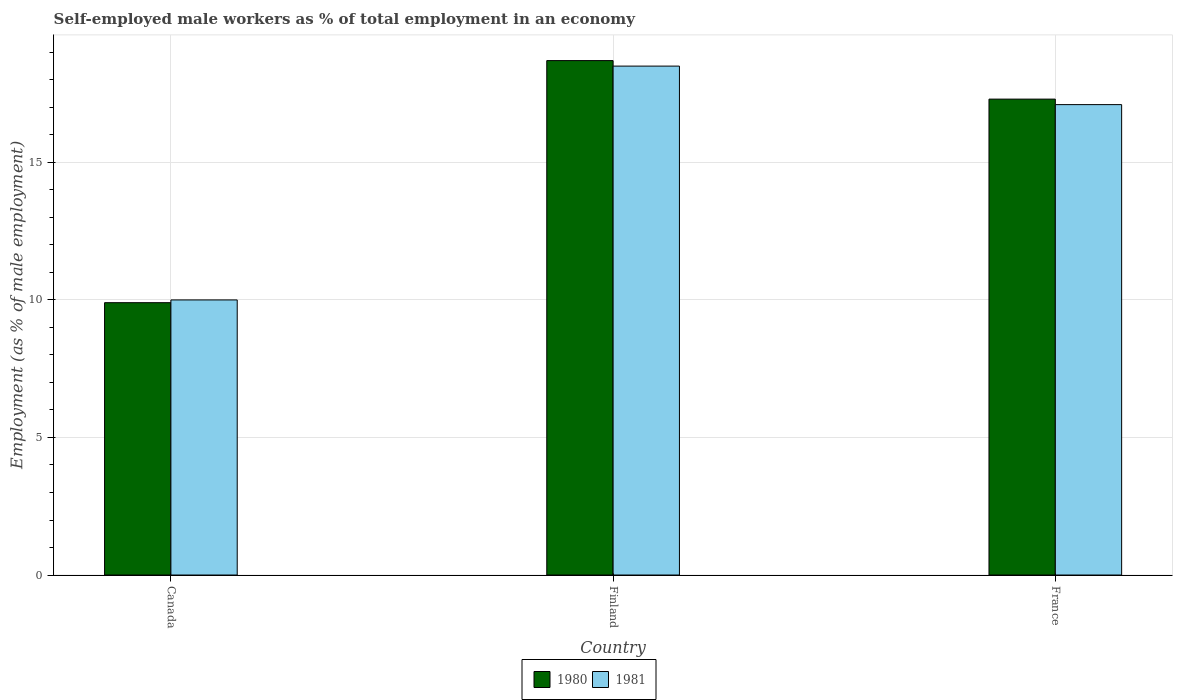Are the number of bars per tick equal to the number of legend labels?
Ensure brevity in your answer.  Yes. How many bars are there on the 3rd tick from the left?
Make the answer very short. 2. How many bars are there on the 3rd tick from the right?
Provide a succinct answer. 2. What is the label of the 2nd group of bars from the left?
Ensure brevity in your answer.  Finland. In how many cases, is the number of bars for a given country not equal to the number of legend labels?
Offer a terse response. 0. What is the percentage of self-employed male workers in 1980 in France?
Your answer should be very brief. 17.3. Across all countries, what is the maximum percentage of self-employed male workers in 1980?
Your answer should be compact. 18.7. What is the total percentage of self-employed male workers in 1980 in the graph?
Offer a terse response. 45.9. What is the difference between the percentage of self-employed male workers in 1980 in Canada and that in France?
Provide a short and direct response. -7.4. What is the difference between the percentage of self-employed male workers in 1980 in Finland and the percentage of self-employed male workers in 1981 in Canada?
Provide a short and direct response. 8.7. What is the average percentage of self-employed male workers in 1980 per country?
Your answer should be compact. 15.3. What is the difference between the percentage of self-employed male workers of/in 1981 and percentage of self-employed male workers of/in 1980 in France?
Give a very brief answer. -0.2. In how many countries, is the percentage of self-employed male workers in 1980 greater than 18 %?
Offer a very short reply. 1. What is the ratio of the percentage of self-employed male workers in 1980 in Canada to that in France?
Your answer should be very brief. 0.57. Is the difference between the percentage of self-employed male workers in 1981 in Finland and France greater than the difference between the percentage of self-employed male workers in 1980 in Finland and France?
Give a very brief answer. No. What is the difference between the highest and the second highest percentage of self-employed male workers in 1981?
Give a very brief answer. -1.4. What is the difference between the highest and the lowest percentage of self-employed male workers in 1980?
Keep it short and to the point. 8.8. What does the 2nd bar from the left in Finland represents?
Offer a terse response. 1981. How many bars are there?
Make the answer very short. 6. Are all the bars in the graph horizontal?
Your response must be concise. No. How many countries are there in the graph?
Your answer should be very brief. 3. Does the graph contain any zero values?
Provide a succinct answer. No. How are the legend labels stacked?
Your answer should be compact. Horizontal. What is the title of the graph?
Your response must be concise. Self-employed male workers as % of total employment in an economy. Does "1975" appear as one of the legend labels in the graph?
Your answer should be compact. No. What is the label or title of the Y-axis?
Offer a terse response. Employment (as % of male employment). What is the Employment (as % of male employment) in 1980 in Canada?
Provide a short and direct response. 9.9. What is the Employment (as % of male employment) of 1981 in Canada?
Provide a succinct answer. 10. What is the Employment (as % of male employment) of 1980 in Finland?
Ensure brevity in your answer.  18.7. What is the Employment (as % of male employment) in 1981 in Finland?
Your response must be concise. 18.5. What is the Employment (as % of male employment) of 1980 in France?
Give a very brief answer. 17.3. What is the Employment (as % of male employment) of 1981 in France?
Give a very brief answer. 17.1. Across all countries, what is the maximum Employment (as % of male employment) in 1980?
Your answer should be very brief. 18.7. Across all countries, what is the maximum Employment (as % of male employment) of 1981?
Your answer should be compact. 18.5. Across all countries, what is the minimum Employment (as % of male employment) of 1980?
Offer a very short reply. 9.9. Across all countries, what is the minimum Employment (as % of male employment) of 1981?
Your answer should be very brief. 10. What is the total Employment (as % of male employment) of 1980 in the graph?
Your response must be concise. 45.9. What is the total Employment (as % of male employment) of 1981 in the graph?
Provide a short and direct response. 45.6. What is the difference between the Employment (as % of male employment) of 1980 in Canada and that in Finland?
Provide a short and direct response. -8.8. What is the difference between the Employment (as % of male employment) in 1980 in Canada and that in France?
Provide a short and direct response. -7.4. What is the difference between the Employment (as % of male employment) of 1981 in Canada and that in France?
Your answer should be compact. -7.1. What is the difference between the Employment (as % of male employment) in 1980 in Canada and the Employment (as % of male employment) in 1981 in Finland?
Provide a short and direct response. -8.6. What is the difference between the Employment (as % of male employment) of 1980 in Canada and the Employment (as % of male employment) of 1981 in France?
Ensure brevity in your answer.  -7.2. What is the difference between the Employment (as % of male employment) of 1980 in Finland and the Employment (as % of male employment) of 1981 in France?
Make the answer very short. 1.6. What is the average Employment (as % of male employment) of 1981 per country?
Provide a short and direct response. 15.2. What is the ratio of the Employment (as % of male employment) in 1980 in Canada to that in Finland?
Make the answer very short. 0.53. What is the ratio of the Employment (as % of male employment) of 1981 in Canada to that in Finland?
Keep it short and to the point. 0.54. What is the ratio of the Employment (as % of male employment) of 1980 in Canada to that in France?
Offer a very short reply. 0.57. What is the ratio of the Employment (as % of male employment) of 1981 in Canada to that in France?
Make the answer very short. 0.58. What is the ratio of the Employment (as % of male employment) in 1980 in Finland to that in France?
Offer a terse response. 1.08. What is the ratio of the Employment (as % of male employment) in 1981 in Finland to that in France?
Offer a terse response. 1.08. What is the difference between the highest and the second highest Employment (as % of male employment) of 1980?
Keep it short and to the point. 1.4. What is the difference between the highest and the second highest Employment (as % of male employment) in 1981?
Provide a short and direct response. 1.4. What is the difference between the highest and the lowest Employment (as % of male employment) of 1980?
Your response must be concise. 8.8. What is the difference between the highest and the lowest Employment (as % of male employment) in 1981?
Give a very brief answer. 8.5. 